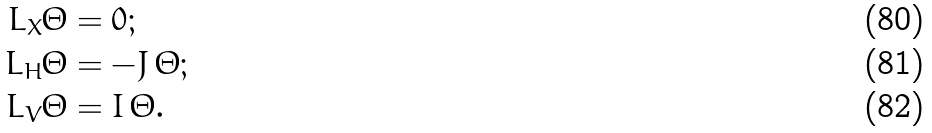<formula> <loc_0><loc_0><loc_500><loc_500>L _ { X } \Theta & = 0 ; \\ L _ { H } \Theta & = - J \, \Theta ; \\ L _ { V } \Theta & = I \, \Theta .</formula> 